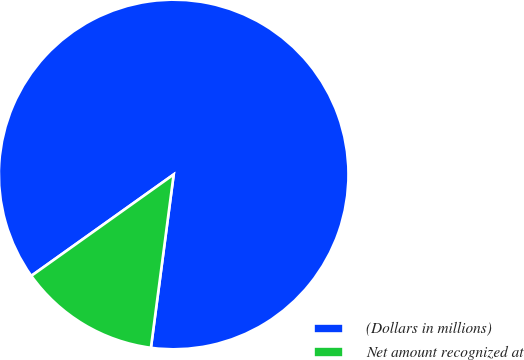Convert chart to OTSL. <chart><loc_0><loc_0><loc_500><loc_500><pie_chart><fcel>(Dollars in millions)<fcel>Net amount recognized at<nl><fcel>86.93%<fcel>13.07%<nl></chart> 